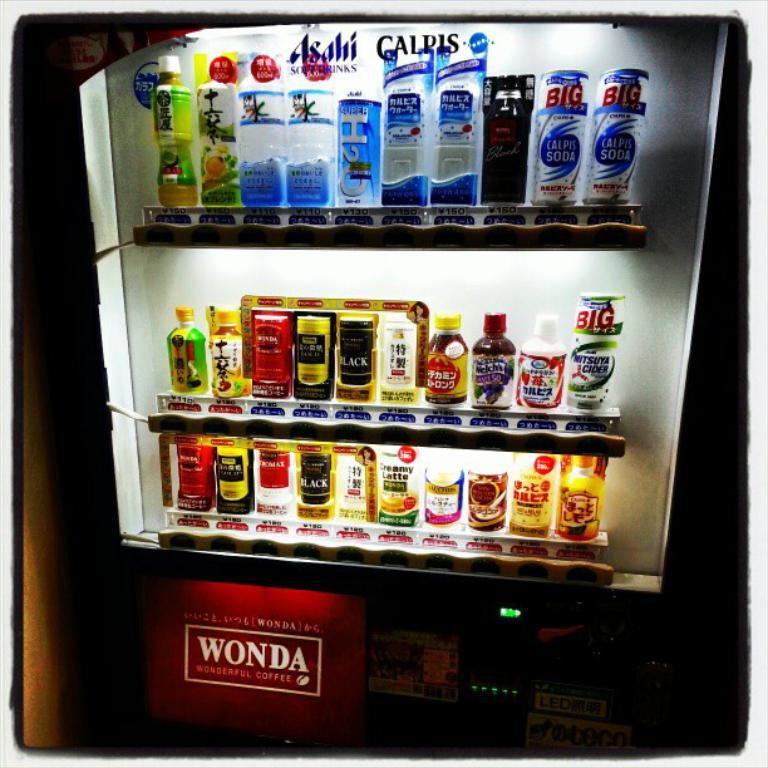Provide a one-sentence caption for the provided image. A vending machine offers beverages from Asahi soft drinks and Calpis. 